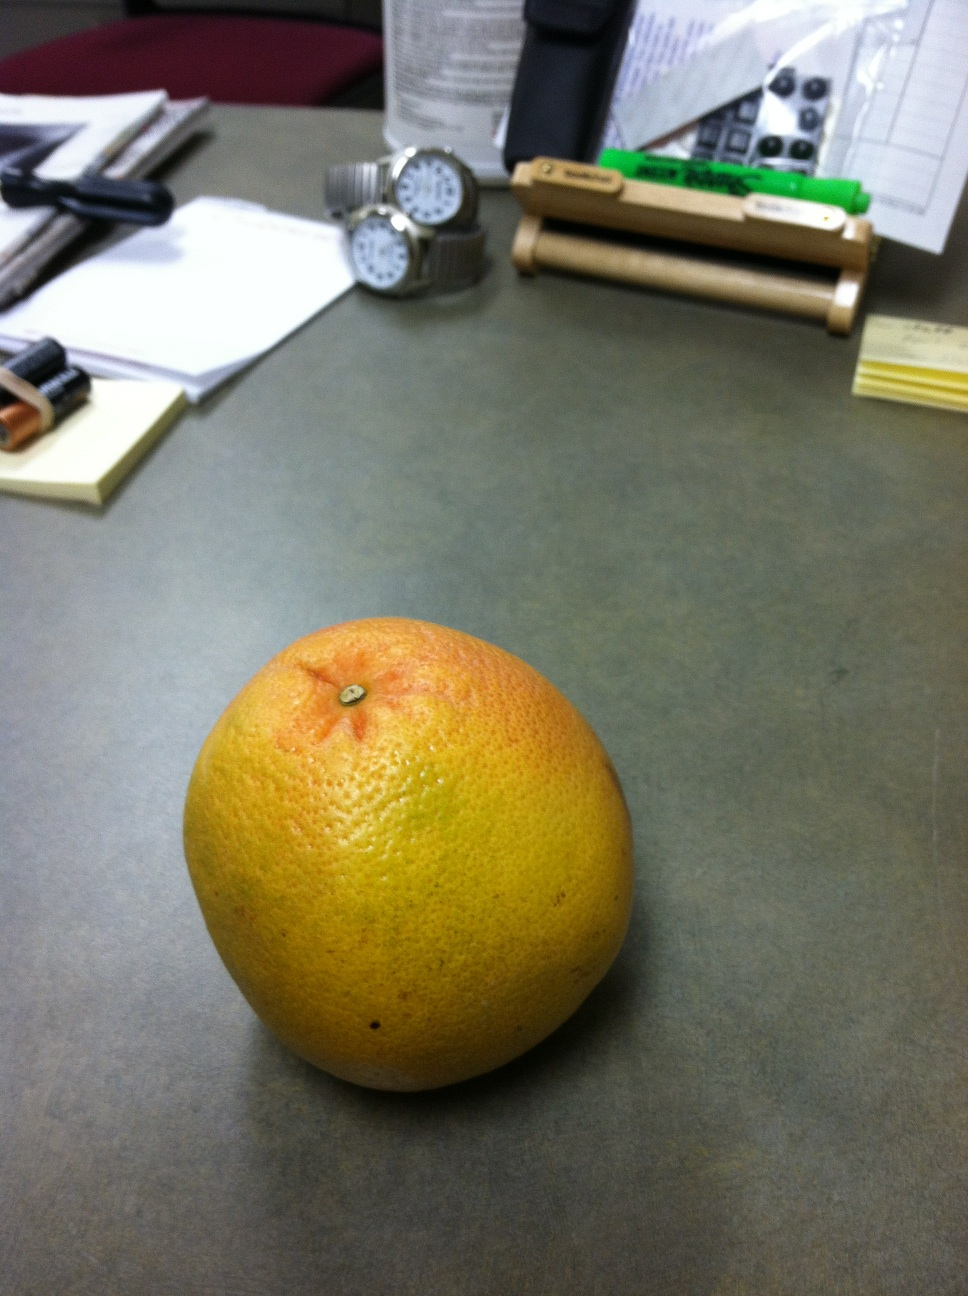Imagine this image is part of a larger scene in a movie. Describe the scene and context. In a dimly lit office, marked by the quiet hum of air conditioning, stands a solitary desk. This desk is not just an ordinary piece of furniture; it's the epicenter of a high-stakes thriller. The grapefruit, a seemingly ordinary fruit, is far from it—it contains a microchip with crucial information that could sway the balance of power. As the camera pans out, the scene unfolds. Papers scattered across the desk are not mere office documents but coded messages. The watches are synchronized instruments, crucial for timing a complex heist. Bios of key figures, plans, and blueprints lie disguised as mundane office work. Our protagonist, a covert operative posing as an office worker, enters the scene. With a keen eye and swift hands, they extract the microchip from the grapefruit, harkening back to their training days. The office door creaks, hinting at an unexpected visitor. Tension builds as the protagonist must hide the evidence, ready to bluff their way through a seemingly innocuous conversation. This scene is a linchpin moment, a calm before the storm in the unfolding espionage drama. 